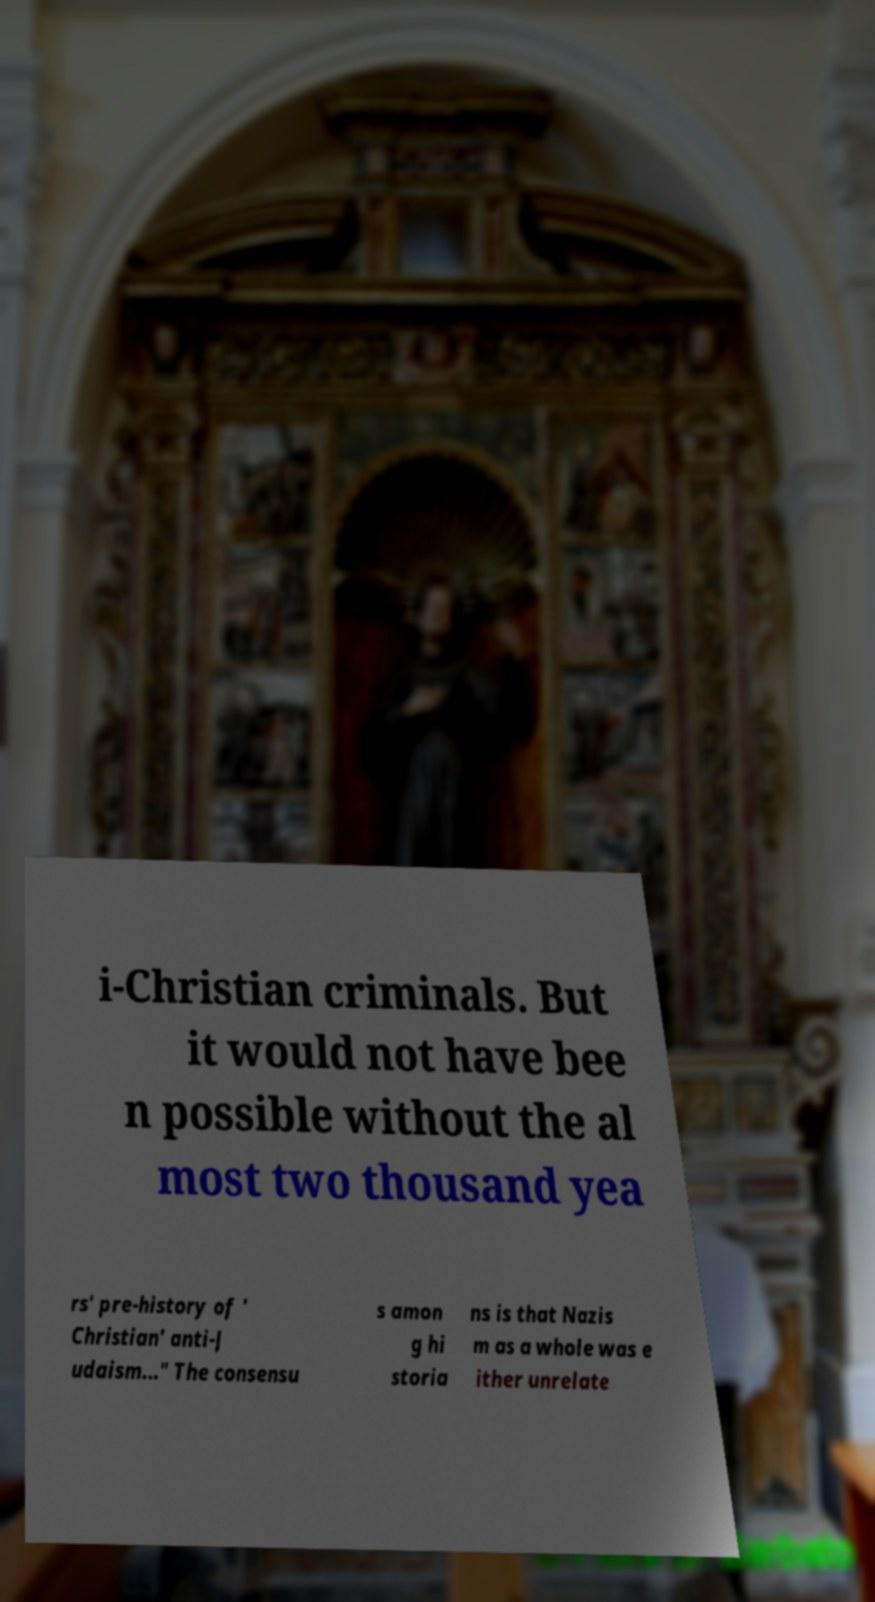Could you extract and type out the text from this image? i-Christian criminals. But it would not have bee n possible without the al most two thousand yea rs' pre-history of ' Christian' anti-J udaism..." The consensu s amon g hi storia ns is that Nazis m as a whole was e ither unrelate 